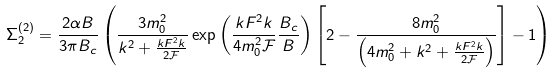<formula> <loc_0><loc_0><loc_500><loc_500>\Sigma _ { 2 } ^ { ( 2 ) } = \frac { 2 \alpha B } { 3 \pi B _ { c } } \left ( \frac { 3 m _ { 0 } ^ { 2 } } { k ^ { 2 } + \frac { k F ^ { 2 } k } { 2 \mathcal { F } } } \exp \left ( \frac { k F ^ { 2 } k } { 4 m _ { 0 } ^ { 2 } \mathcal { F } } \frac { B _ { c } } { B } \right ) \left [ 2 - \frac { 8 m _ { 0 } ^ { 2 } } { \left ( 4 m _ { 0 } ^ { 2 } + k ^ { 2 } + \frac { k F ^ { 2 } k } { 2 \mathcal { F } } \right ) } \right ] - 1 \right )</formula> 